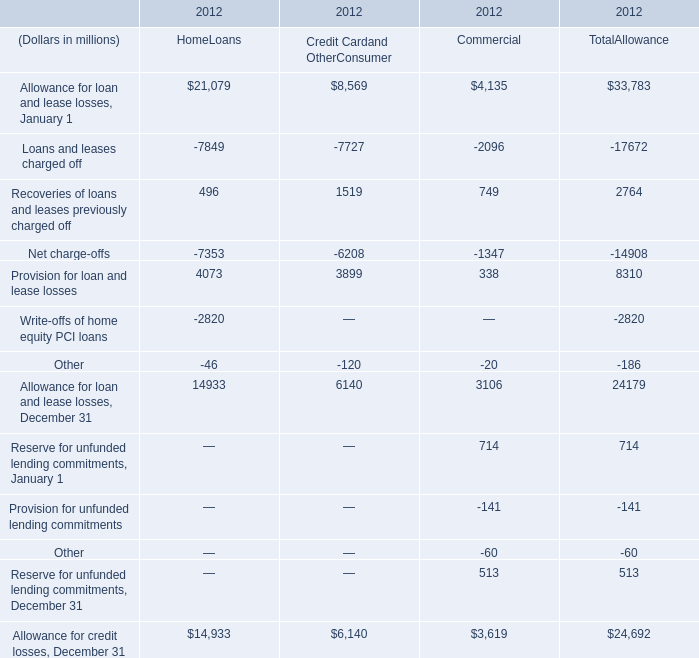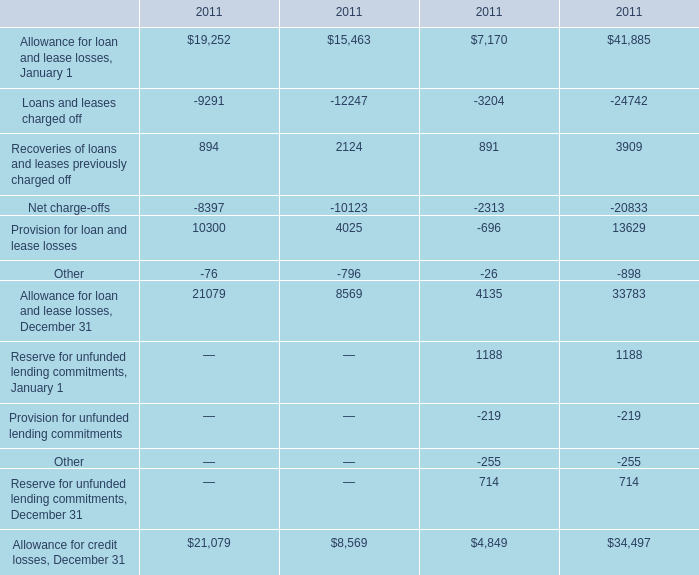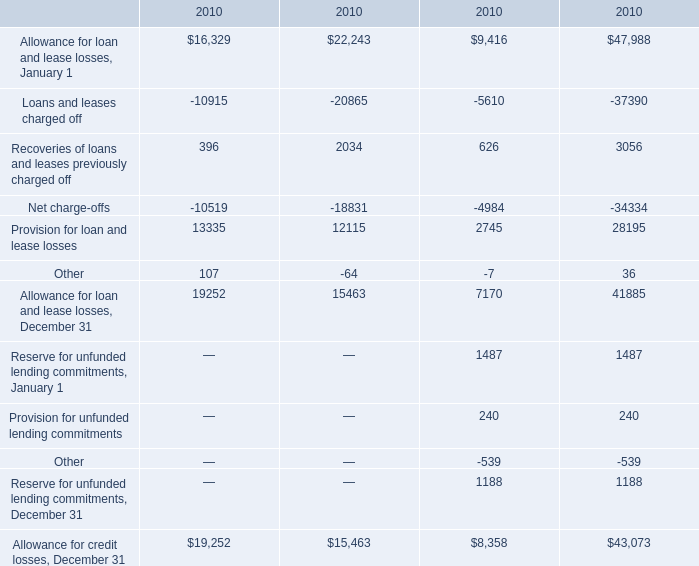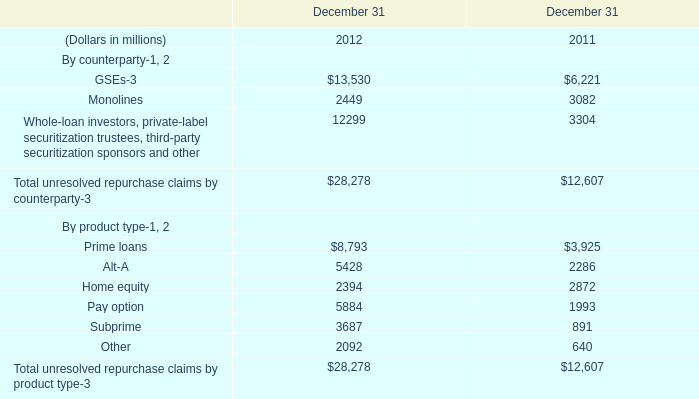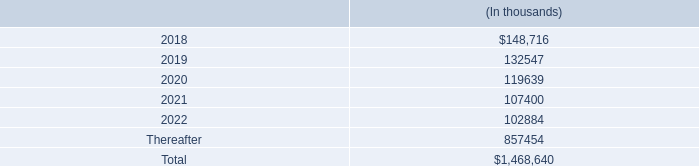In the allowance type with the greatest proportion of provision for loan and lease losses, what is the proportion of allowance for credit losses to the total? 
Computations: (14933 / 24692)
Answer: 0.60477. 